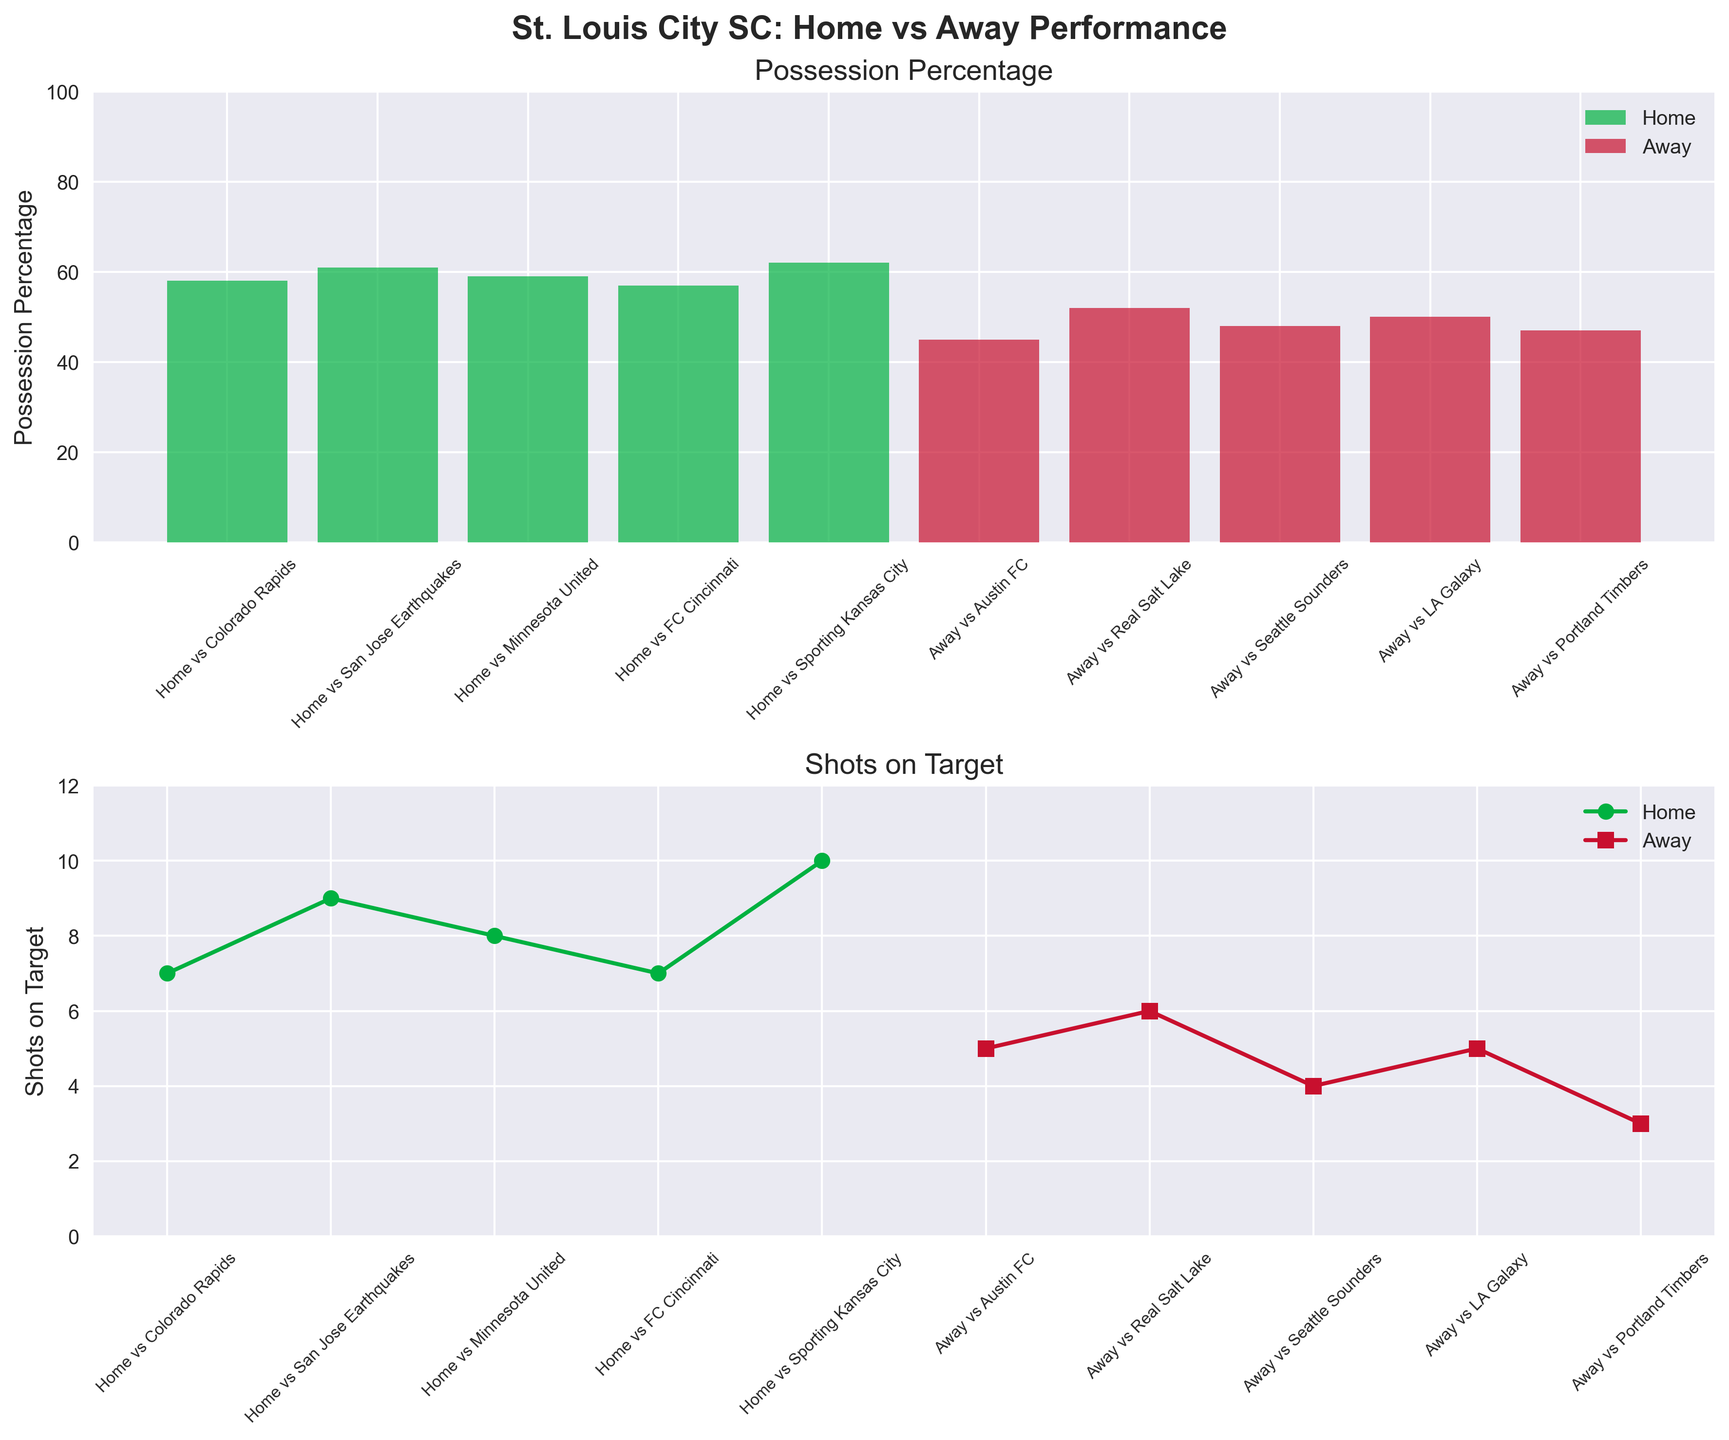What are the colors used in the bar chart of possession percentage? The bar chart uses green for home games and red for away games. This distinction is visible in the legend as well.
Answer: Green, red What's the title of the figure? The title of the figure is displayed prominently at the top.
Answer: St. Louis City SC: Home vs Away Performance How many total games are depicted in the figure? By counting the data points listed on the x-axis in both subplots, we can see there are 10 games in total: 5 home games and 5 away games.
Answer: 10 Which home game had the highest possession percentage? By looking at the bar heights in the possession percentage subplot and checking the labels, we see that the home game against Sporting Kansas City had the highest possession percentage.
Answer: Home vs Sporting Kansas City Which away game had the lowest number of shots on target? By examining the lowest data point on the away games plot for shots on target, we can identify that the away game against Portland Timbers had the lowest number.
Answer: Away vs Portland Timbers On average, how many shots on target did St. Louis City SC have in home games? List the shots on target for home games: 7, 9, 8, 7, 10. Sum them (7 + 9 + 8 + 7 + 10 = 41) and divide by the number of home games (41 / 5).
Answer: 8.2 Did St. Louis City SC have more possession in home games or away games on average? Calculate the average possession for home games (58 + 61 + 59 + 57 + 62) / 5 and for away games (45 + 52 + 48 + 50 + 47) / 5. Compare both averages. Home average: 59.4. Away average: 48.4.
Answer: Home games Is there a correlation between possession percentage and shots on target for home games? By visually inspecting the two subplots for home games, a higher possession percentage generally seems to correspond to more shots on target, suggesting a positive correlation.
Answer: Yes Which game stands out for having a high possession percentage but relatively few shots on target? By examining both possession percentage and shots on target subplots, the away game against Real Salt Lake stands out with 52% possession and only 6 shots on target compared to other games with similar possession.
Answer: Away vs Real Salt Lake What is the difference in possession percentage between the highest and lowest home games? Find the possession percentages for the highest (62%) and lowest (57%) home games and subtract the lowest from the highest.
Answer: 5 